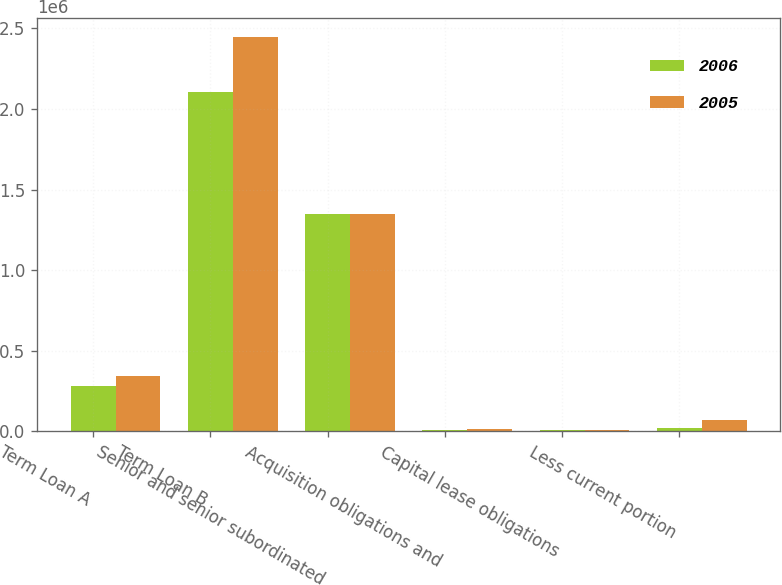Convert chart to OTSL. <chart><loc_0><loc_0><loc_500><loc_500><stacked_bar_chart><ecel><fcel>Term Loan A<fcel>Term Loan B<fcel>Senior and senior subordinated<fcel>Acquisition obligations and<fcel>Capital lease obligations<fcel>Less current portion<nl><fcel>2006<fcel>279250<fcel>2.10588e+06<fcel>1.35e+06<fcel>9197<fcel>6929<fcel>20871<nl><fcel>2005<fcel>341250<fcel>2.44388e+06<fcel>1.35e+06<fcel>14757<fcel>7320<fcel>71767<nl></chart> 